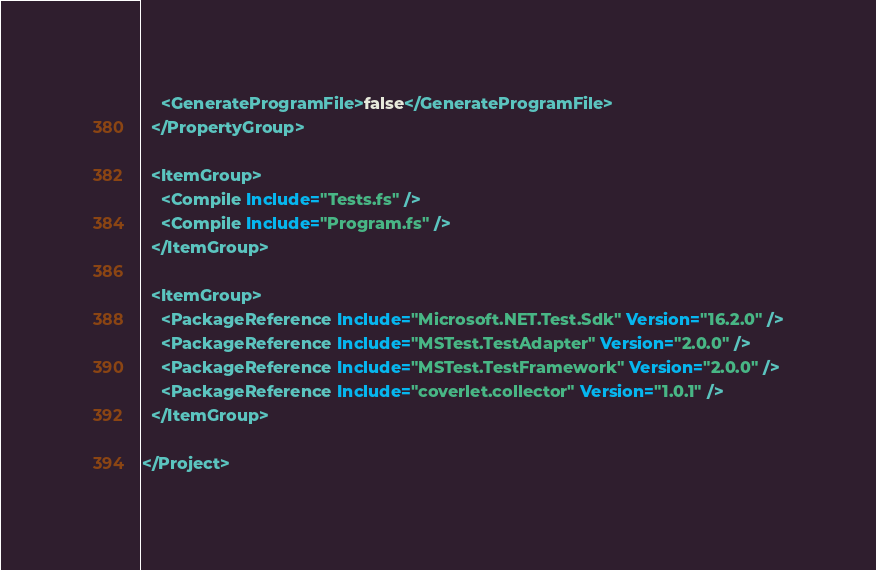<code> <loc_0><loc_0><loc_500><loc_500><_XML_>    <GenerateProgramFile>false</GenerateProgramFile>
  </PropertyGroup>

  <ItemGroup>
    <Compile Include="Tests.fs" />
    <Compile Include="Program.fs" />
  </ItemGroup>

  <ItemGroup>
    <PackageReference Include="Microsoft.NET.Test.Sdk" Version="16.2.0" />
    <PackageReference Include="MSTest.TestAdapter" Version="2.0.0" />
    <PackageReference Include="MSTest.TestFramework" Version="2.0.0" />
    <PackageReference Include="coverlet.collector" Version="1.0.1" />
  </ItemGroup>

</Project>
</code> 